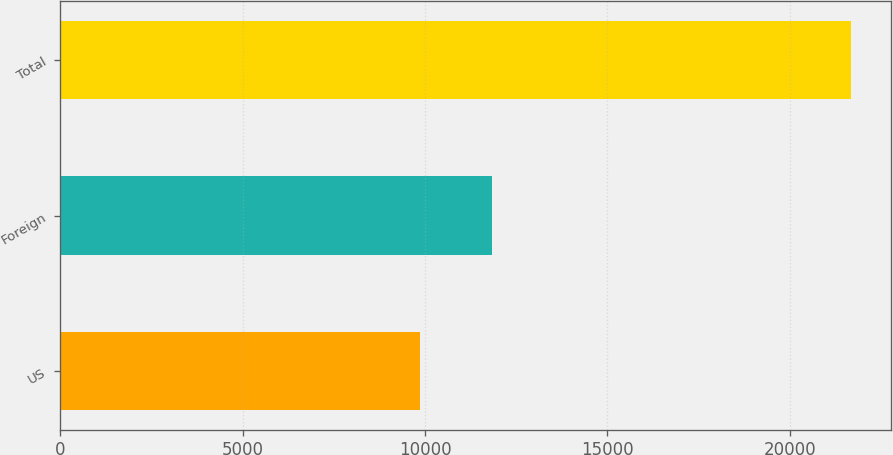<chart> <loc_0><loc_0><loc_500><loc_500><bar_chart><fcel>US<fcel>Foreign<fcel>Total<nl><fcel>9862<fcel>11825<fcel>21687<nl></chart> 